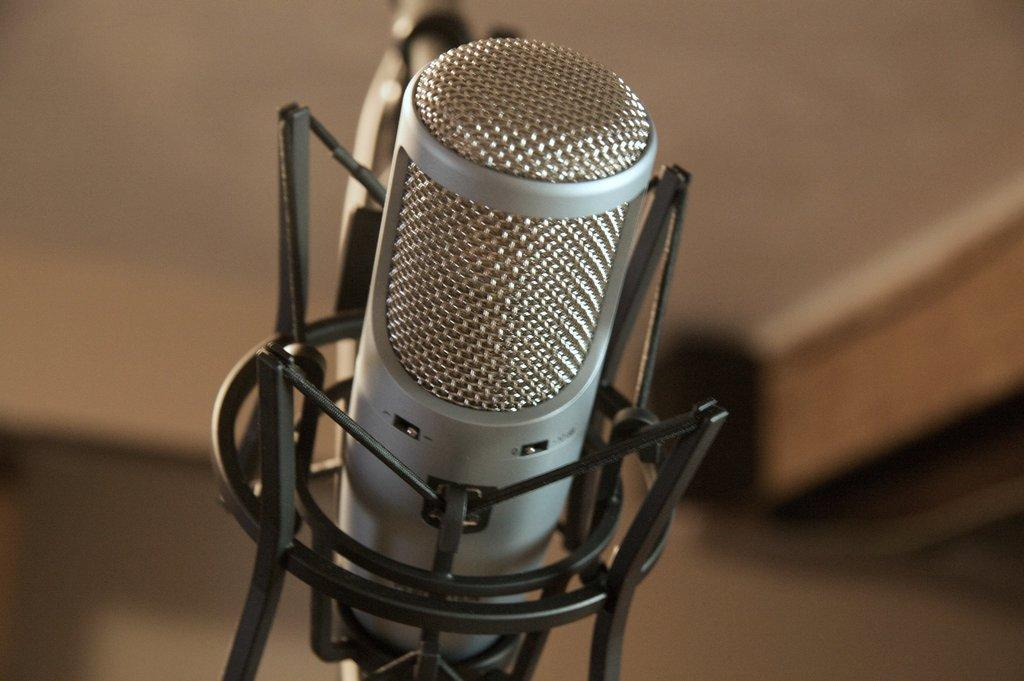What object is the main focus of the image? There is a microphone in the image. Can you describe the background of the image? The background of the image is blurred. How many ants can be seen crawling on the microphone in the image? There are no ants present in the image. Is there a goat visible in the background of the image? There is no goat present in the image. 